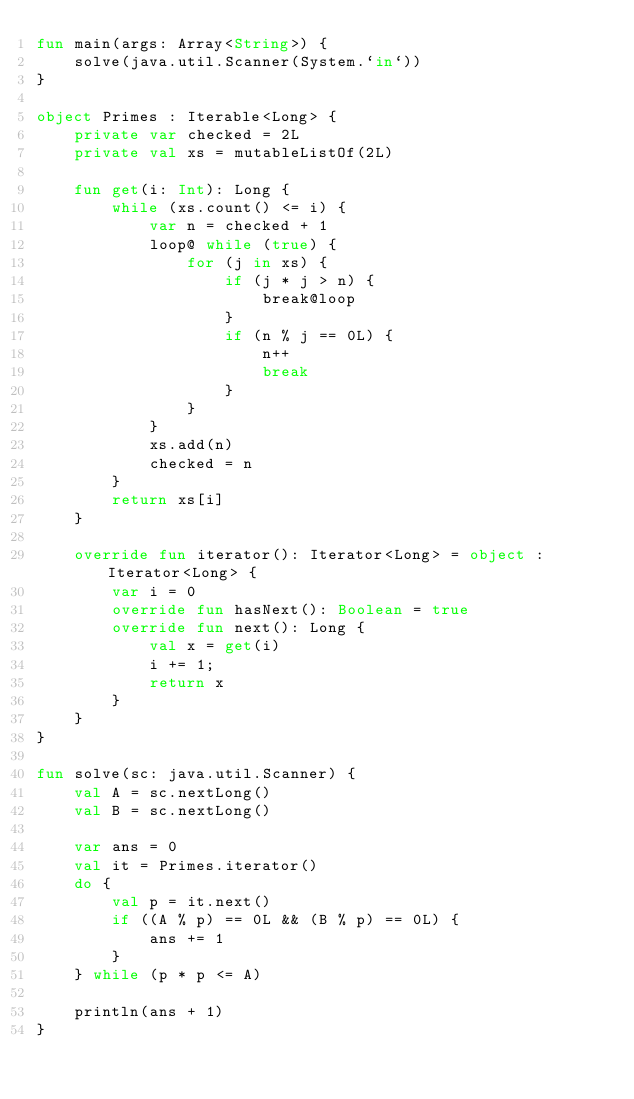<code> <loc_0><loc_0><loc_500><loc_500><_Kotlin_>fun main(args: Array<String>) {
    solve(java.util.Scanner(System.`in`))
}

object Primes : Iterable<Long> {
    private var checked = 2L
    private val xs = mutableListOf(2L)

    fun get(i: Int): Long {
        while (xs.count() <= i) {
            var n = checked + 1
            loop@ while (true) {
                for (j in xs) {
                    if (j * j > n) {
                        break@loop
                    }
                    if (n % j == 0L) {
                        n++
                        break
                    }
                }
            }
            xs.add(n)
            checked = n
        }
        return xs[i]
    }

    override fun iterator(): Iterator<Long> = object : Iterator<Long> {
        var i = 0
        override fun hasNext(): Boolean = true
        override fun next(): Long {
            val x = get(i)
            i += 1;
            return x
        }
    }
}

fun solve(sc: java.util.Scanner) {
    val A = sc.nextLong()
    val B = sc.nextLong()

    var ans = 0
    val it = Primes.iterator()
    do {
        val p = it.next()
        if ((A % p) == 0L && (B % p) == 0L) {
            ans += 1
        }
    } while (p * p <= A)

    println(ans + 1)
}
</code> 